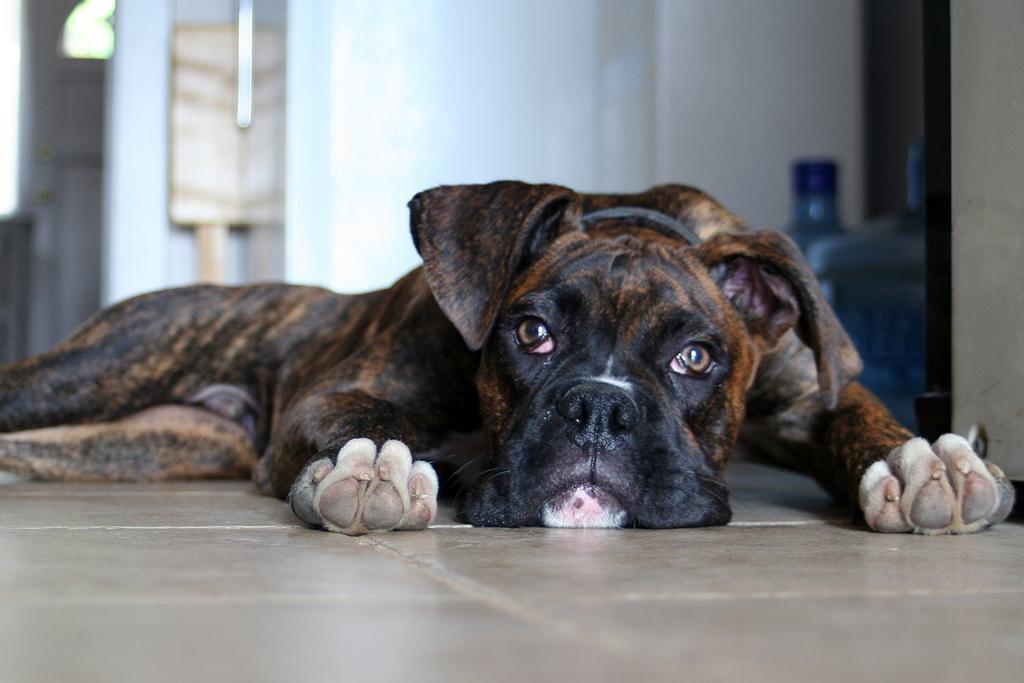Could you give a brief overview of what you see in this image? In this picture we can see a dog on the ground and in the background we can see a wall, water cans and some objects. 